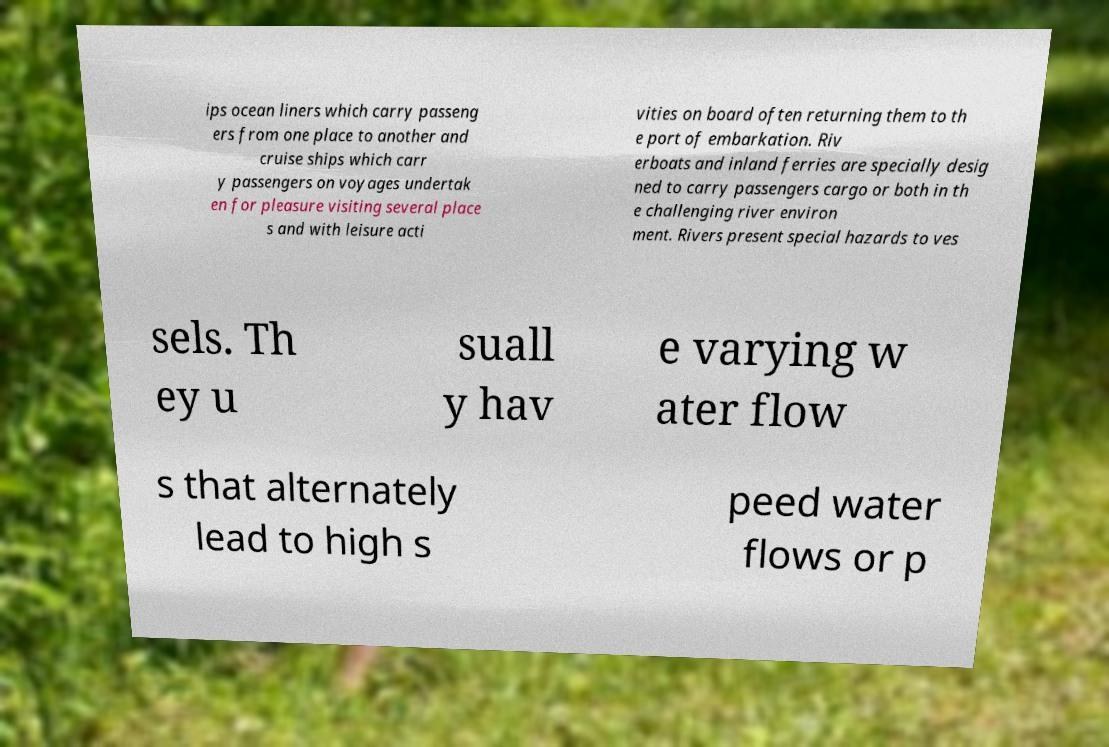What messages or text are displayed in this image? I need them in a readable, typed format. ips ocean liners which carry passeng ers from one place to another and cruise ships which carr y passengers on voyages undertak en for pleasure visiting several place s and with leisure acti vities on board often returning them to th e port of embarkation. Riv erboats and inland ferries are specially desig ned to carry passengers cargo or both in th e challenging river environ ment. Rivers present special hazards to ves sels. Th ey u suall y hav e varying w ater flow s that alternately lead to high s peed water flows or p 